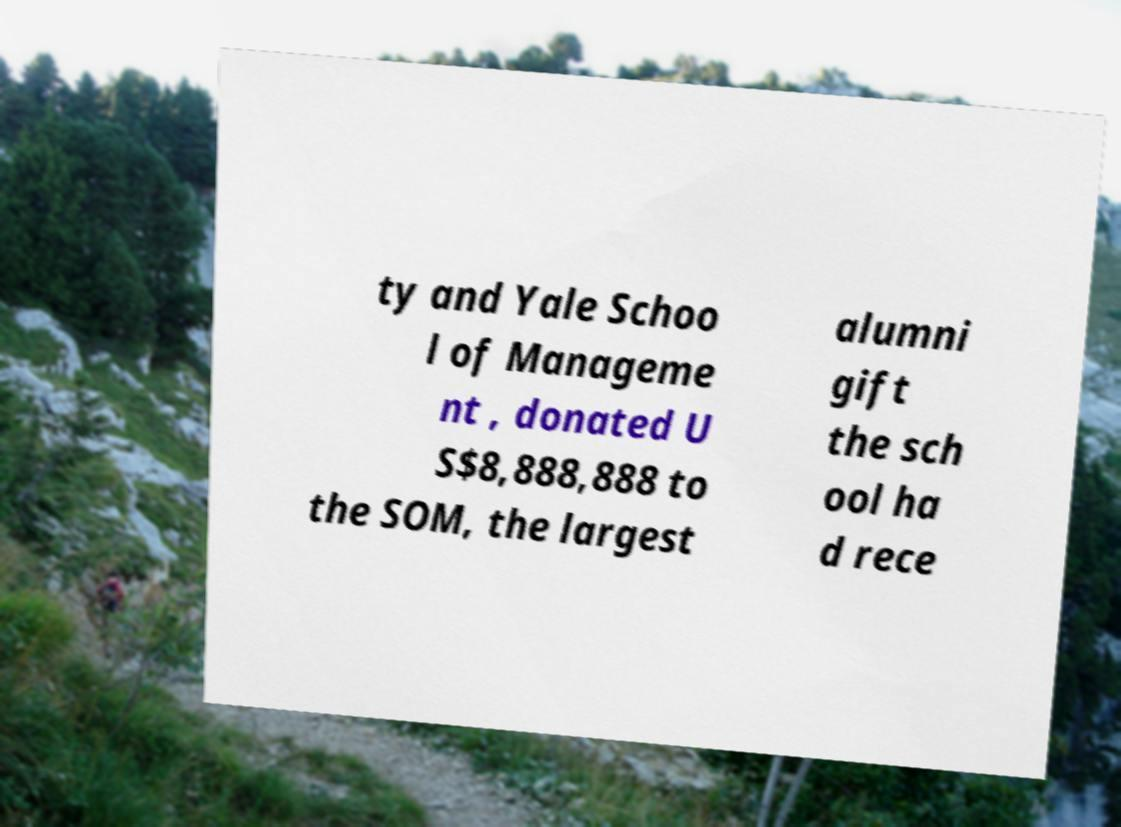Please identify and transcribe the text found in this image. ty and Yale Schoo l of Manageme nt , donated U S$8,888,888 to the SOM, the largest alumni gift the sch ool ha d rece 